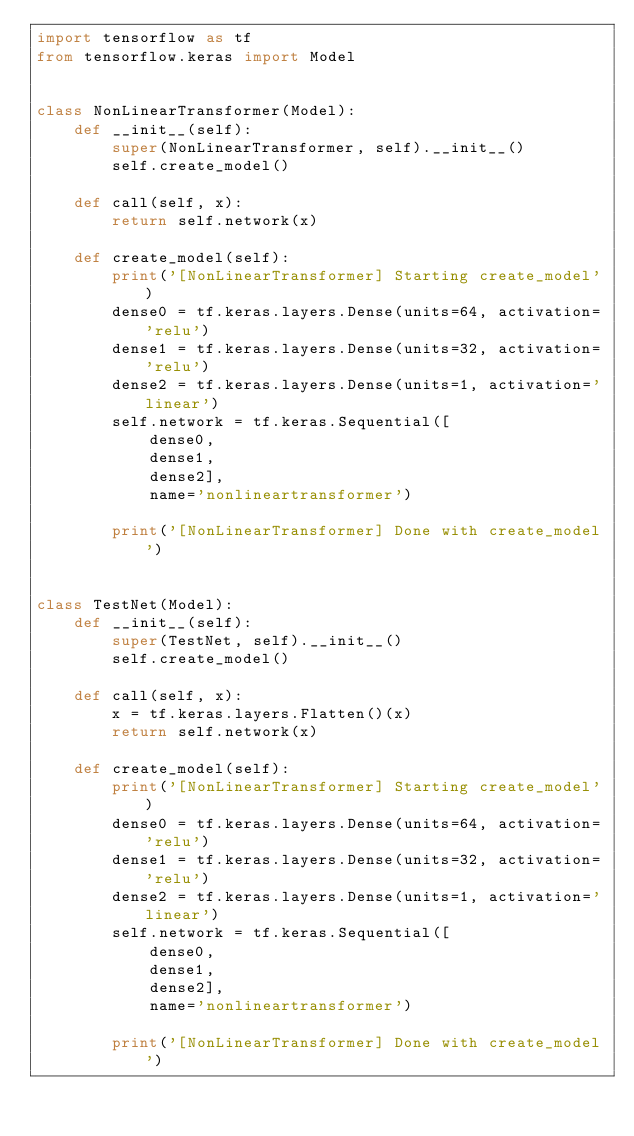<code> <loc_0><loc_0><loc_500><loc_500><_Python_>import tensorflow as tf
from tensorflow.keras import Model


class NonLinearTransformer(Model):
    def __init__(self):
        super(NonLinearTransformer, self).__init__()
        self.create_model()

    def call(self, x):
        return self.network(x)

    def create_model(self):
        print('[NonLinearTransformer] Starting create_model')
        dense0 = tf.keras.layers.Dense(units=64, activation='relu')
        dense1 = tf.keras.layers.Dense(units=32, activation='relu')
        dense2 = tf.keras.layers.Dense(units=1, activation='linear')
        self.network = tf.keras.Sequential([
            dense0,
            dense1,
            dense2],
            name='nonlineartransformer')

        print('[NonLinearTransformer] Done with create_model')


class TestNet(Model):
    def __init__(self):
        super(TestNet, self).__init__()
        self.create_model()

    def call(self, x):
        x = tf.keras.layers.Flatten()(x)
        return self.network(x)

    def create_model(self):
        print('[NonLinearTransformer] Starting create_model')
        dense0 = tf.keras.layers.Dense(units=64, activation='relu')
        dense1 = tf.keras.layers.Dense(units=32, activation='relu')
        dense2 = tf.keras.layers.Dense(units=1, activation='linear')
        self.network = tf.keras.Sequential([
            dense0,
            dense1,
            dense2],
            name='nonlineartransformer')

        print('[NonLinearTransformer] Done with create_model')
</code> 